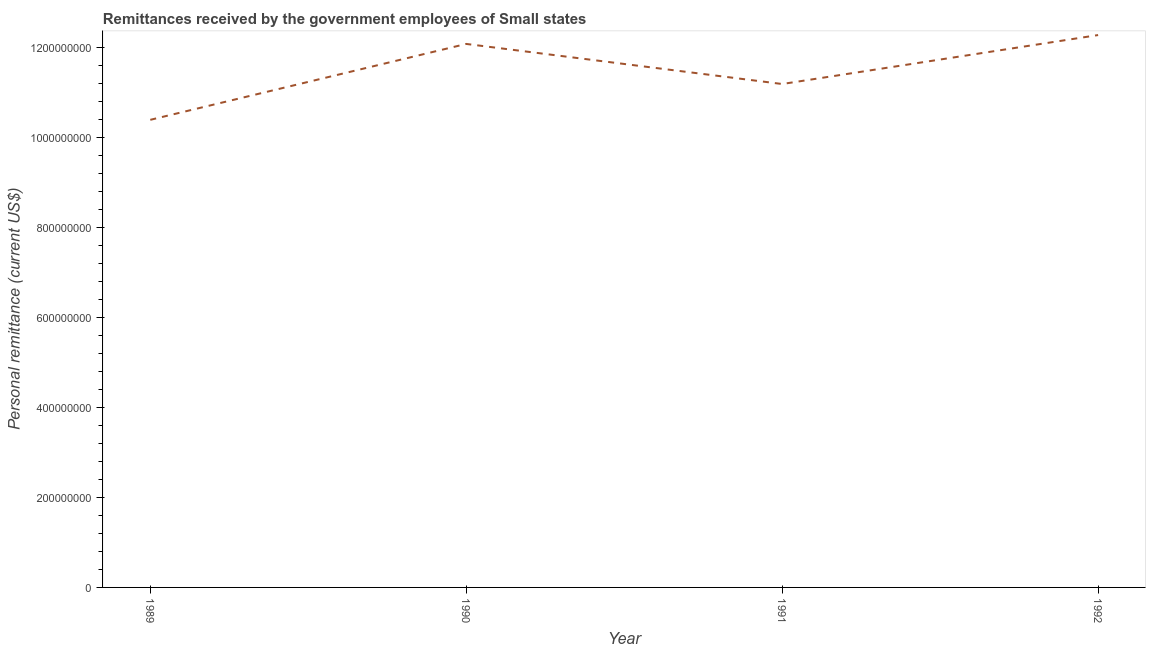What is the personal remittances in 1992?
Make the answer very short. 1.23e+09. Across all years, what is the maximum personal remittances?
Offer a terse response. 1.23e+09. Across all years, what is the minimum personal remittances?
Keep it short and to the point. 1.04e+09. In which year was the personal remittances maximum?
Give a very brief answer. 1992. In which year was the personal remittances minimum?
Keep it short and to the point. 1989. What is the sum of the personal remittances?
Offer a terse response. 4.59e+09. What is the difference between the personal remittances in 1990 and 1992?
Give a very brief answer. -1.97e+07. What is the average personal remittances per year?
Offer a very short reply. 1.15e+09. What is the median personal remittances?
Your response must be concise. 1.16e+09. In how many years, is the personal remittances greater than 840000000 US$?
Provide a short and direct response. 4. Do a majority of the years between 1989 and 1991 (inclusive) have personal remittances greater than 680000000 US$?
Make the answer very short. Yes. What is the ratio of the personal remittances in 1990 to that in 1992?
Offer a very short reply. 0.98. Is the personal remittances in 1990 less than that in 1992?
Your answer should be compact. Yes. What is the difference between the highest and the second highest personal remittances?
Offer a terse response. 1.97e+07. What is the difference between the highest and the lowest personal remittances?
Keep it short and to the point. 1.88e+08. How many years are there in the graph?
Give a very brief answer. 4. Are the values on the major ticks of Y-axis written in scientific E-notation?
Your response must be concise. No. Does the graph contain any zero values?
Your answer should be very brief. No. What is the title of the graph?
Give a very brief answer. Remittances received by the government employees of Small states. What is the label or title of the Y-axis?
Provide a short and direct response. Personal remittance (current US$). What is the Personal remittance (current US$) of 1989?
Keep it short and to the point. 1.04e+09. What is the Personal remittance (current US$) in 1990?
Give a very brief answer. 1.21e+09. What is the Personal remittance (current US$) in 1991?
Give a very brief answer. 1.12e+09. What is the Personal remittance (current US$) of 1992?
Your answer should be very brief. 1.23e+09. What is the difference between the Personal remittance (current US$) in 1989 and 1990?
Offer a very short reply. -1.69e+08. What is the difference between the Personal remittance (current US$) in 1989 and 1991?
Offer a very short reply. -7.95e+07. What is the difference between the Personal remittance (current US$) in 1989 and 1992?
Offer a terse response. -1.88e+08. What is the difference between the Personal remittance (current US$) in 1990 and 1991?
Keep it short and to the point. 8.90e+07. What is the difference between the Personal remittance (current US$) in 1990 and 1992?
Keep it short and to the point. -1.97e+07. What is the difference between the Personal remittance (current US$) in 1991 and 1992?
Ensure brevity in your answer.  -1.09e+08. What is the ratio of the Personal remittance (current US$) in 1989 to that in 1990?
Make the answer very short. 0.86. What is the ratio of the Personal remittance (current US$) in 1989 to that in 1991?
Offer a very short reply. 0.93. What is the ratio of the Personal remittance (current US$) in 1989 to that in 1992?
Give a very brief answer. 0.85. What is the ratio of the Personal remittance (current US$) in 1990 to that in 1992?
Your answer should be very brief. 0.98. What is the ratio of the Personal remittance (current US$) in 1991 to that in 1992?
Offer a terse response. 0.91. 